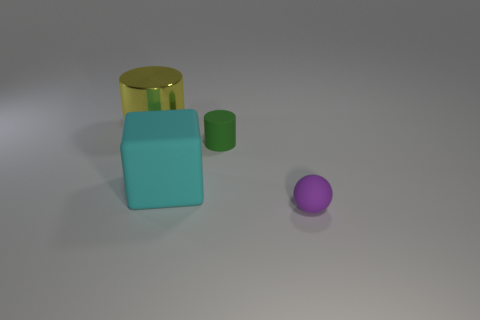Is the number of tiny green cubes greater than the number of matte blocks? no 